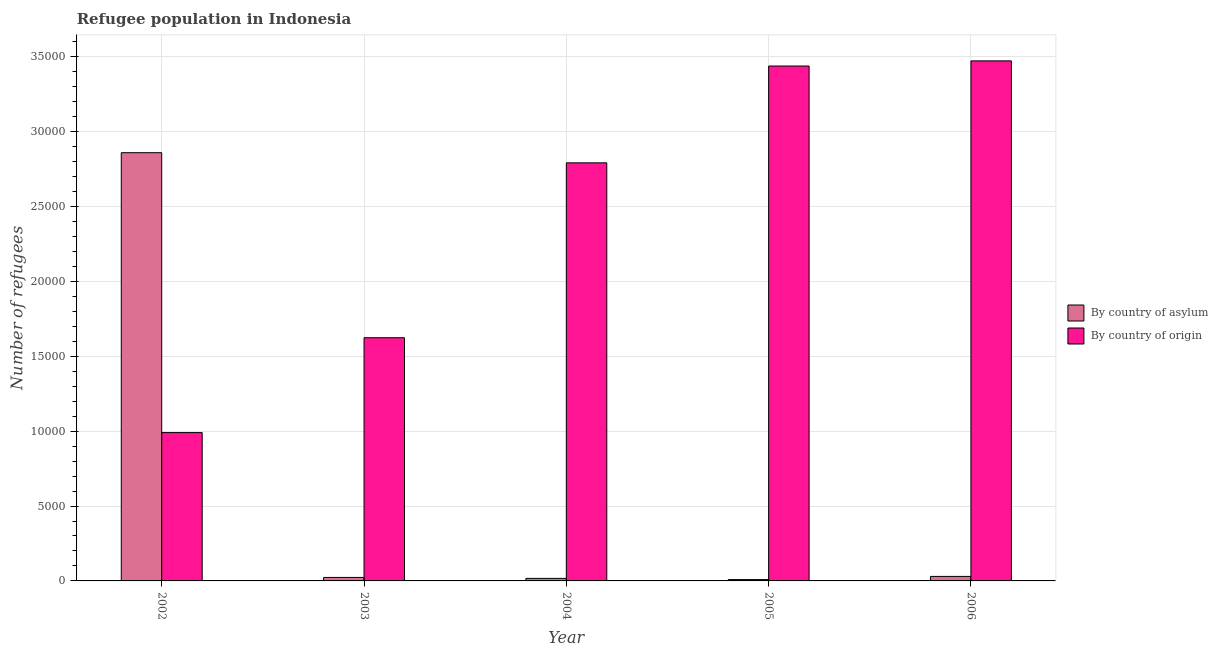How many groups of bars are there?
Make the answer very short. 5. Are the number of bars per tick equal to the number of legend labels?
Offer a terse response. Yes. Are the number of bars on each tick of the X-axis equal?
Your answer should be very brief. Yes. What is the number of refugees by country of asylum in 2006?
Provide a succinct answer. 301. Across all years, what is the maximum number of refugees by country of asylum?
Offer a very short reply. 2.86e+04. Across all years, what is the minimum number of refugees by country of asylum?
Ensure brevity in your answer.  89. In which year was the number of refugees by country of origin minimum?
Provide a short and direct response. 2002. What is the total number of refugees by country of origin in the graph?
Your answer should be compact. 1.23e+05. What is the difference between the number of refugees by country of origin in 2004 and that in 2006?
Give a very brief answer. -6809. What is the difference between the number of refugees by country of origin in 2006 and the number of refugees by country of asylum in 2002?
Provide a short and direct response. 2.48e+04. What is the average number of refugees by country of asylum per year?
Your response must be concise. 5877.6. What is the ratio of the number of refugees by country of asylum in 2003 to that in 2005?
Offer a very short reply. 2.62. Is the number of refugees by country of asylum in 2002 less than that in 2005?
Offer a terse response. No. What is the difference between the highest and the second highest number of refugees by country of origin?
Offer a terse response. 344. What is the difference between the highest and the lowest number of refugees by country of asylum?
Ensure brevity in your answer.  2.85e+04. In how many years, is the number of refugees by country of origin greater than the average number of refugees by country of origin taken over all years?
Offer a very short reply. 3. Is the sum of the number of refugees by country of asylum in 2002 and 2004 greater than the maximum number of refugees by country of origin across all years?
Your response must be concise. Yes. What does the 1st bar from the left in 2002 represents?
Your response must be concise. By country of asylum. What does the 1st bar from the right in 2002 represents?
Provide a short and direct response. By country of origin. Are all the bars in the graph horizontal?
Your response must be concise. No. How many years are there in the graph?
Ensure brevity in your answer.  5. What is the difference between two consecutive major ticks on the Y-axis?
Your response must be concise. 5000. Are the values on the major ticks of Y-axis written in scientific E-notation?
Offer a terse response. No. Does the graph contain any zero values?
Provide a succinct answer. No. Where does the legend appear in the graph?
Make the answer very short. Center right. What is the title of the graph?
Your answer should be compact. Refugee population in Indonesia. Does "Primary income" appear as one of the legend labels in the graph?
Keep it short and to the point. No. What is the label or title of the Y-axis?
Your answer should be very brief. Number of refugees. What is the Number of refugees of By country of asylum in 2002?
Give a very brief answer. 2.86e+04. What is the Number of refugees in By country of origin in 2002?
Ensure brevity in your answer.  9906. What is the Number of refugees in By country of asylum in 2003?
Make the answer very short. 233. What is the Number of refugees of By country of origin in 2003?
Offer a very short reply. 1.62e+04. What is the Number of refugees of By country of asylum in 2004?
Provide a short and direct response. 169. What is the Number of refugees of By country of origin in 2004?
Give a very brief answer. 2.79e+04. What is the Number of refugees in By country of asylum in 2005?
Make the answer very short. 89. What is the Number of refugees of By country of origin in 2005?
Your answer should be compact. 3.44e+04. What is the Number of refugees of By country of asylum in 2006?
Offer a terse response. 301. What is the Number of refugees in By country of origin in 2006?
Your response must be concise. 3.47e+04. Across all years, what is the maximum Number of refugees in By country of asylum?
Make the answer very short. 2.86e+04. Across all years, what is the maximum Number of refugees of By country of origin?
Ensure brevity in your answer.  3.47e+04. Across all years, what is the minimum Number of refugees in By country of asylum?
Your answer should be very brief. 89. Across all years, what is the minimum Number of refugees of By country of origin?
Your answer should be very brief. 9906. What is the total Number of refugees in By country of asylum in the graph?
Your answer should be very brief. 2.94e+04. What is the total Number of refugees of By country of origin in the graph?
Keep it short and to the point. 1.23e+05. What is the difference between the Number of refugees of By country of asylum in 2002 and that in 2003?
Offer a very short reply. 2.84e+04. What is the difference between the Number of refugees of By country of origin in 2002 and that in 2003?
Provide a succinct answer. -6334. What is the difference between the Number of refugees in By country of asylum in 2002 and that in 2004?
Give a very brief answer. 2.84e+04. What is the difference between the Number of refugees in By country of origin in 2002 and that in 2004?
Your answer should be very brief. -1.80e+04. What is the difference between the Number of refugees of By country of asylum in 2002 and that in 2005?
Offer a very short reply. 2.85e+04. What is the difference between the Number of refugees of By country of origin in 2002 and that in 2005?
Your answer should be compact. -2.45e+04. What is the difference between the Number of refugees of By country of asylum in 2002 and that in 2006?
Your answer should be compact. 2.83e+04. What is the difference between the Number of refugees in By country of origin in 2002 and that in 2006?
Your answer should be compact. -2.48e+04. What is the difference between the Number of refugees in By country of origin in 2003 and that in 2004?
Offer a terse response. -1.17e+04. What is the difference between the Number of refugees of By country of asylum in 2003 and that in 2005?
Your answer should be very brief. 144. What is the difference between the Number of refugees of By country of origin in 2003 and that in 2005?
Provide a succinct answer. -1.81e+04. What is the difference between the Number of refugees in By country of asylum in 2003 and that in 2006?
Provide a short and direct response. -68. What is the difference between the Number of refugees in By country of origin in 2003 and that in 2006?
Keep it short and to the point. -1.85e+04. What is the difference between the Number of refugees of By country of origin in 2004 and that in 2005?
Provide a succinct answer. -6465. What is the difference between the Number of refugees of By country of asylum in 2004 and that in 2006?
Provide a short and direct response. -132. What is the difference between the Number of refugees in By country of origin in 2004 and that in 2006?
Offer a very short reply. -6809. What is the difference between the Number of refugees in By country of asylum in 2005 and that in 2006?
Ensure brevity in your answer.  -212. What is the difference between the Number of refugees of By country of origin in 2005 and that in 2006?
Make the answer very short. -344. What is the difference between the Number of refugees in By country of asylum in 2002 and the Number of refugees in By country of origin in 2003?
Make the answer very short. 1.24e+04. What is the difference between the Number of refugees of By country of asylum in 2002 and the Number of refugees of By country of origin in 2004?
Your answer should be very brief. 677. What is the difference between the Number of refugees in By country of asylum in 2002 and the Number of refugees in By country of origin in 2005?
Keep it short and to the point. -5788. What is the difference between the Number of refugees in By country of asylum in 2002 and the Number of refugees in By country of origin in 2006?
Make the answer very short. -6132. What is the difference between the Number of refugees of By country of asylum in 2003 and the Number of refugees of By country of origin in 2004?
Make the answer very short. -2.77e+04. What is the difference between the Number of refugees in By country of asylum in 2003 and the Number of refugees in By country of origin in 2005?
Give a very brief answer. -3.42e+04. What is the difference between the Number of refugees of By country of asylum in 2003 and the Number of refugees of By country of origin in 2006?
Give a very brief answer. -3.45e+04. What is the difference between the Number of refugees of By country of asylum in 2004 and the Number of refugees of By country of origin in 2005?
Provide a succinct answer. -3.42e+04. What is the difference between the Number of refugees in By country of asylum in 2004 and the Number of refugees in By country of origin in 2006?
Keep it short and to the point. -3.46e+04. What is the difference between the Number of refugees of By country of asylum in 2005 and the Number of refugees of By country of origin in 2006?
Provide a short and direct response. -3.46e+04. What is the average Number of refugees of By country of asylum per year?
Offer a terse response. 5877.6. What is the average Number of refugees in By country of origin per year?
Provide a short and direct response. 2.46e+04. In the year 2002, what is the difference between the Number of refugees of By country of asylum and Number of refugees of By country of origin?
Ensure brevity in your answer.  1.87e+04. In the year 2003, what is the difference between the Number of refugees in By country of asylum and Number of refugees in By country of origin?
Offer a terse response. -1.60e+04. In the year 2004, what is the difference between the Number of refugees of By country of asylum and Number of refugees of By country of origin?
Give a very brief answer. -2.78e+04. In the year 2005, what is the difference between the Number of refugees in By country of asylum and Number of refugees in By country of origin?
Provide a succinct answer. -3.43e+04. In the year 2006, what is the difference between the Number of refugees of By country of asylum and Number of refugees of By country of origin?
Keep it short and to the point. -3.44e+04. What is the ratio of the Number of refugees in By country of asylum in 2002 to that in 2003?
Offer a terse response. 122.73. What is the ratio of the Number of refugees of By country of origin in 2002 to that in 2003?
Your response must be concise. 0.61. What is the ratio of the Number of refugees of By country of asylum in 2002 to that in 2004?
Your answer should be compact. 169.21. What is the ratio of the Number of refugees in By country of origin in 2002 to that in 2004?
Your answer should be compact. 0.35. What is the ratio of the Number of refugees of By country of asylum in 2002 to that in 2005?
Ensure brevity in your answer.  321.3. What is the ratio of the Number of refugees in By country of origin in 2002 to that in 2005?
Your answer should be compact. 0.29. What is the ratio of the Number of refugees in By country of asylum in 2002 to that in 2006?
Provide a succinct answer. 95. What is the ratio of the Number of refugees in By country of origin in 2002 to that in 2006?
Your response must be concise. 0.29. What is the ratio of the Number of refugees in By country of asylum in 2003 to that in 2004?
Offer a very short reply. 1.38. What is the ratio of the Number of refugees of By country of origin in 2003 to that in 2004?
Your answer should be very brief. 0.58. What is the ratio of the Number of refugees of By country of asylum in 2003 to that in 2005?
Offer a very short reply. 2.62. What is the ratio of the Number of refugees in By country of origin in 2003 to that in 2005?
Keep it short and to the point. 0.47. What is the ratio of the Number of refugees of By country of asylum in 2003 to that in 2006?
Provide a succinct answer. 0.77. What is the ratio of the Number of refugees in By country of origin in 2003 to that in 2006?
Provide a short and direct response. 0.47. What is the ratio of the Number of refugees in By country of asylum in 2004 to that in 2005?
Provide a short and direct response. 1.9. What is the ratio of the Number of refugees of By country of origin in 2004 to that in 2005?
Your answer should be compact. 0.81. What is the ratio of the Number of refugees in By country of asylum in 2004 to that in 2006?
Your answer should be compact. 0.56. What is the ratio of the Number of refugees in By country of origin in 2004 to that in 2006?
Your response must be concise. 0.8. What is the ratio of the Number of refugees in By country of asylum in 2005 to that in 2006?
Your answer should be very brief. 0.3. What is the difference between the highest and the second highest Number of refugees of By country of asylum?
Offer a very short reply. 2.83e+04. What is the difference between the highest and the second highest Number of refugees of By country of origin?
Your answer should be compact. 344. What is the difference between the highest and the lowest Number of refugees of By country of asylum?
Your answer should be compact. 2.85e+04. What is the difference between the highest and the lowest Number of refugees in By country of origin?
Offer a terse response. 2.48e+04. 